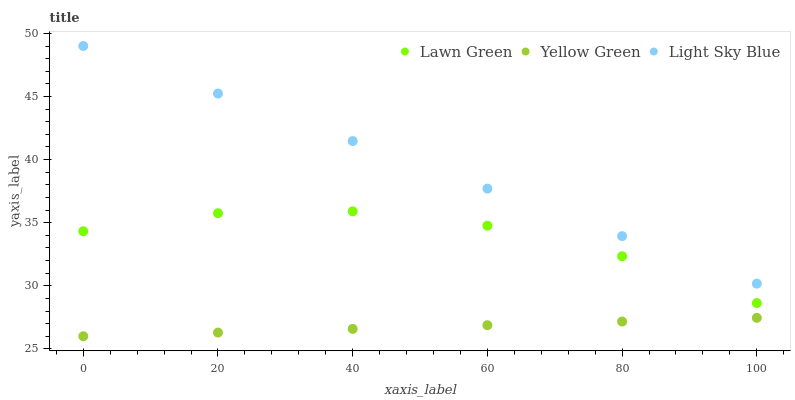Does Yellow Green have the minimum area under the curve?
Answer yes or no. Yes. Does Light Sky Blue have the maximum area under the curve?
Answer yes or no. Yes. Does Light Sky Blue have the minimum area under the curve?
Answer yes or no. No. Does Yellow Green have the maximum area under the curve?
Answer yes or no. No. Is Light Sky Blue the smoothest?
Answer yes or no. Yes. Is Lawn Green the roughest?
Answer yes or no. Yes. Is Yellow Green the smoothest?
Answer yes or no. No. Is Yellow Green the roughest?
Answer yes or no. No. Does Yellow Green have the lowest value?
Answer yes or no. Yes. Does Light Sky Blue have the lowest value?
Answer yes or no. No. Does Light Sky Blue have the highest value?
Answer yes or no. Yes. Does Yellow Green have the highest value?
Answer yes or no. No. Is Lawn Green less than Light Sky Blue?
Answer yes or no. Yes. Is Light Sky Blue greater than Yellow Green?
Answer yes or no. Yes. Does Lawn Green intersect Light Sky Blue?
Answer yes or no. No. 